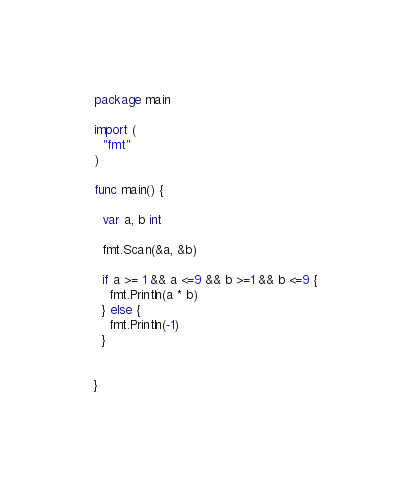<code> <loc_0><loc_0><loc_500><loc_500><_Go_>package main

import (
  "fmt"
)

func main() {

  var a, b int

  fmt.Scan(&a, &b)

  if a >= 1 && a <=9 && b >=1 && b <=9 {
    fmt.Println(a * b)
  } else {
    fmt.Println(-1)
  }
  

}</code> 